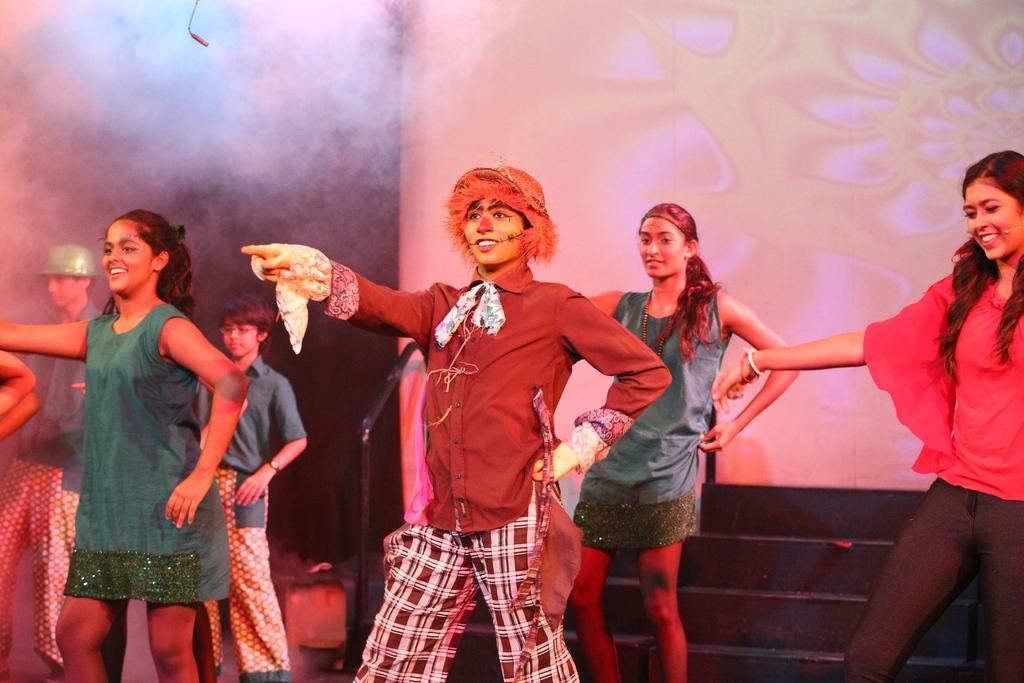Describe this image in one or two sentences. In the image few people are standing and smiling. Behind them there is wall. 